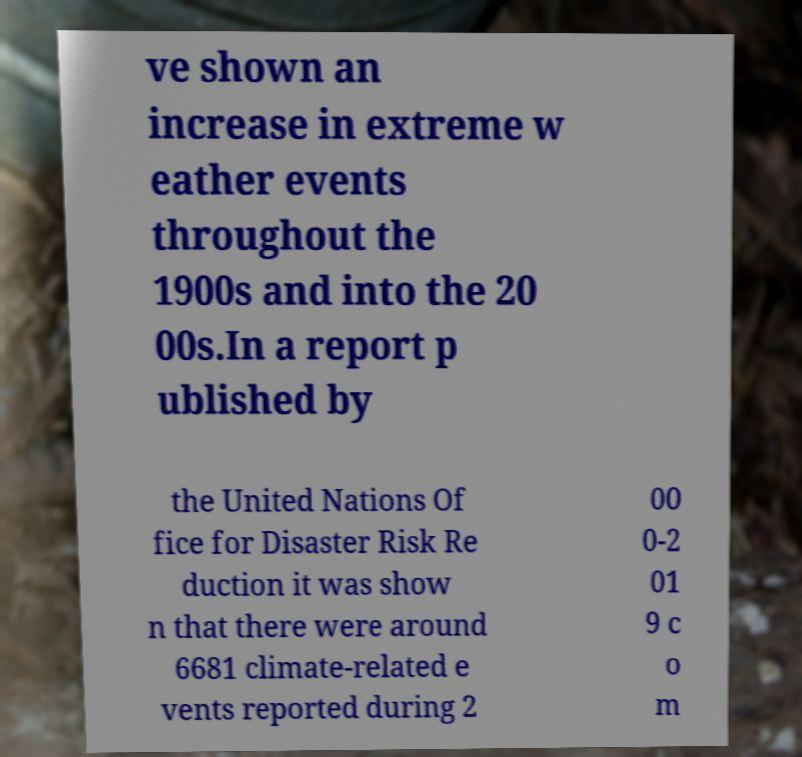Could you extract and type out the text from this image? ve shown an increase in extreme w eather events throughout the 1900s and into the 20 00s.In a report p ublished by the United Nations Of fice for Disaster Risk Re duction it was show n that there were around 6681 climate-related e vents reported during 2 00 0-2 01 9 c o m 